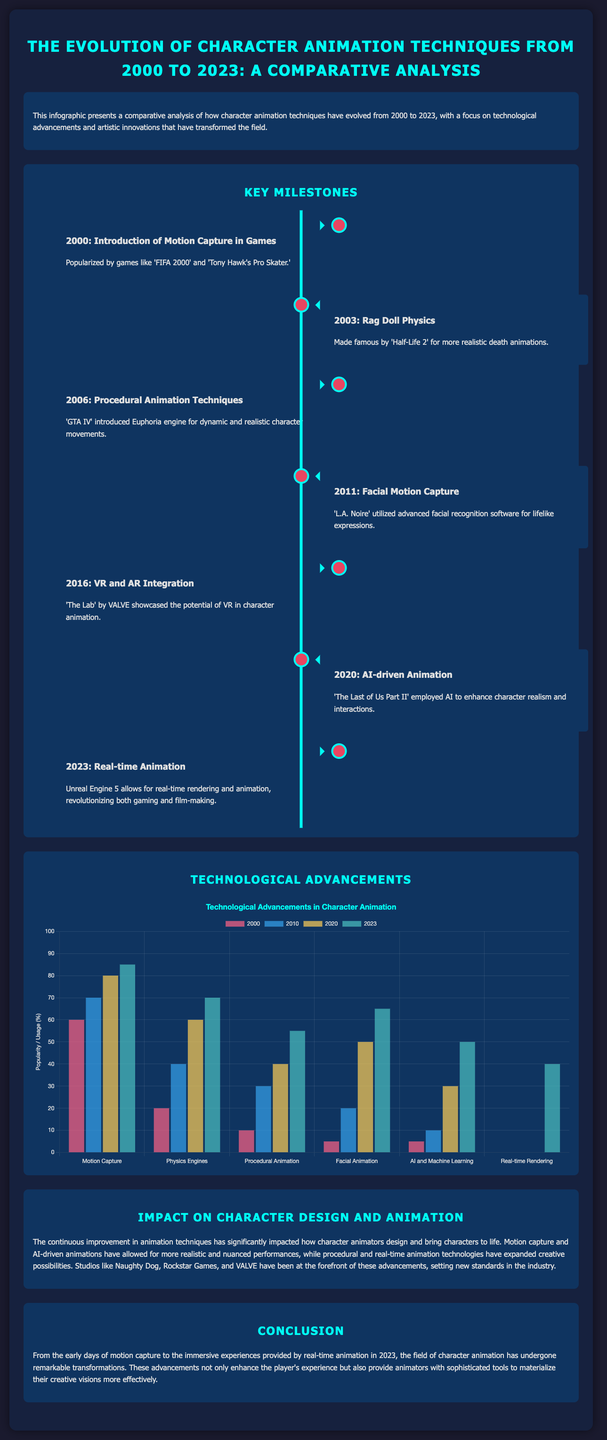What was introduced in 2000? The document states that motion capture was introduced in games in 2000, popularized by 'FIFA 2000' and 'Tony Hawk's Pro Skater'.
Answer: Motion Capture What game showcased rag doll physics in 2003? The document mentions 'Half-Life 2' as the game that made rag doll physics famous.
Answer: Half-Life 2 What technique was introduced with 'GTA IV' in 2006? The document highlights that the Euphoria engine for dynamic and realistic character movements was introduced.
Answer: Procedural Animation Techniques How many technological advancements are listed in the chart? The chart displays six technological advancements related to character animation techniques.
Answer: Six In what year did AI-driven animation appear according to the document? The document indicates that AI-driven animation was used in 'The Last of Us Part II' in 2020.
Answer: 2020 Which studio is recognized for advancements in animation mentioned in the document? The document notes that Naughty Dog is one of the studios at the forefront of animation advancements.
Answer: Naughty Dog Which technology allows for real-time rendering as stated in 2023? According to the document, Unreal Engine 5 allows for real-time rendering and animation.
Answer: Unreal Engine 5 What is the title of the document? The document is titled "The Evolution of Character Animation Techniques from 2000 to 2023: A Comparative Analysis."
Answer: The Evolution of Character Animation Techniques from 2000 to 2023: A Comparative Analysis What percentage usage of motion capture occurred in 2000? The document states that motion capture had a usage of 60% in the year 2000.
Answer: 60% 